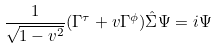<formula> <loc_0><loc_0><loc_500><loc_500>\frac { 1 } { \sqrt { 1 - v ^ { 2 } } } ( \Gamma ^ { \tau } + v \Gamma ^ { \phi } ) \hat { \Sigma } \Psi = i \Psi</formula> 